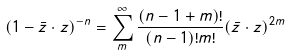<formula> <loc_0><loc_0><loc_500><loc_500>( 1 - \bar { z } \cdot z ) ^ { - n } = \sum _ { m } ^ { \infty } \frac { ( n - 1 + m ) ! } { ( n - 1 ) ! m ! } ( \bar { z } \cdot z ) ^ { 2 m }</formula> 